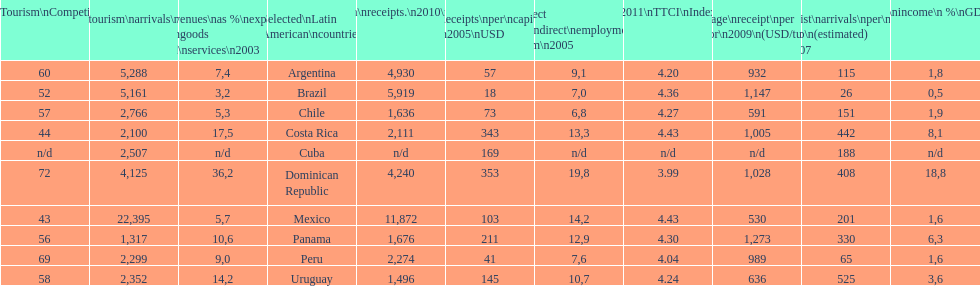What country ranks the best in most categories? Dominican Republic. 